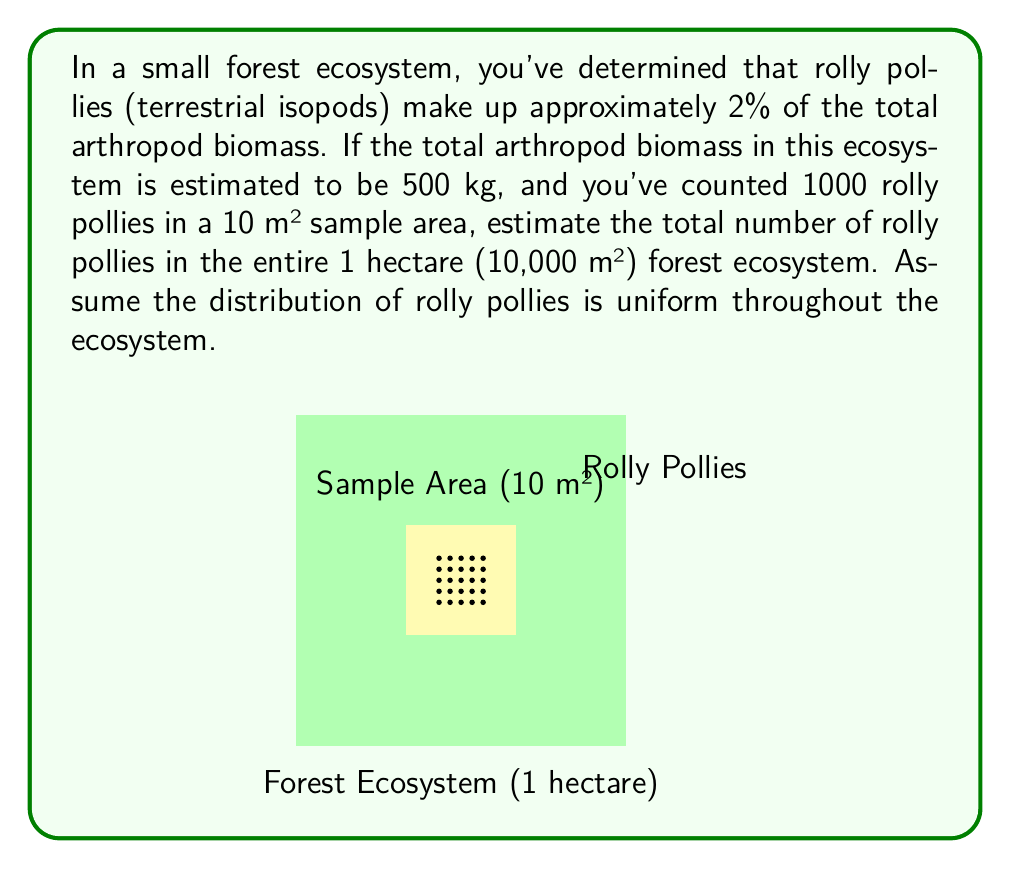Teach me how to tackle this problem. Let's approach this problem step-by-step:

1) First, calculate the biomass of rolly pollies in the ecosystem:
   $$ \text{Rolly Polly Biomass} = 2\% \times 500 \text{ kg} = 0.02 \times 500 \text{ kg} = 10 \text{ kg} $$

2) Now, we need to find the ratio of the sample area to the total area:
   $$ \text{Area Ratio} = \frac{10 \text{ m}^2}{10,000 \text{ m}^2} = \frac{1}{1000} $$

3) Assuming uniform distribution, we can set up a proportion:
   $$ \frac{\text{Sample Rolly Pollies}}{\text{Total Rolly Pollies}} = \frac{\text{Sample Area}}{\text{Total Area}} $$

4) Substituting the known values:
   $$ \frac{1000}{\text{Total Rolly Pollies}} = \frac{1}{1000} $$

5) Cross multiply:
   $$ 1000 \times \text{Total Rolly Pollies} = 1000 \times 1000 $$

6) Solve for Total Rolly Pollies:
   $$ \text{Total Rolly Pollies} = \frac{1000 \times 1000}{1000} = 1,000,000 $$

Therefore, we estimate there are 1,000,000 rolly pollies in the entire forest ecosystem.
Answer: 1,000,000 rolly pollies 